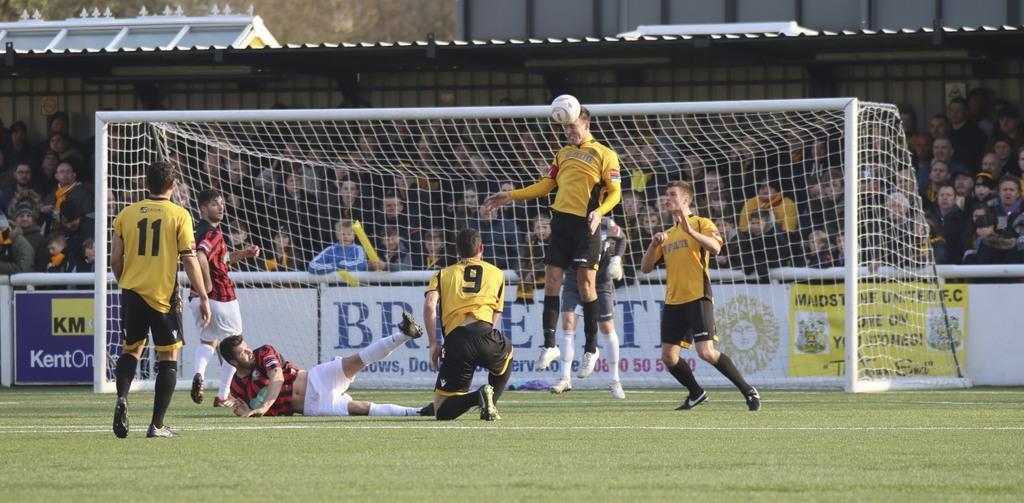In one or two sentences, can you explain what this image depicts? This is a picture of a field where we have seven sports player and a ball and behind them there is a shed in which there are a group of people sitting. 